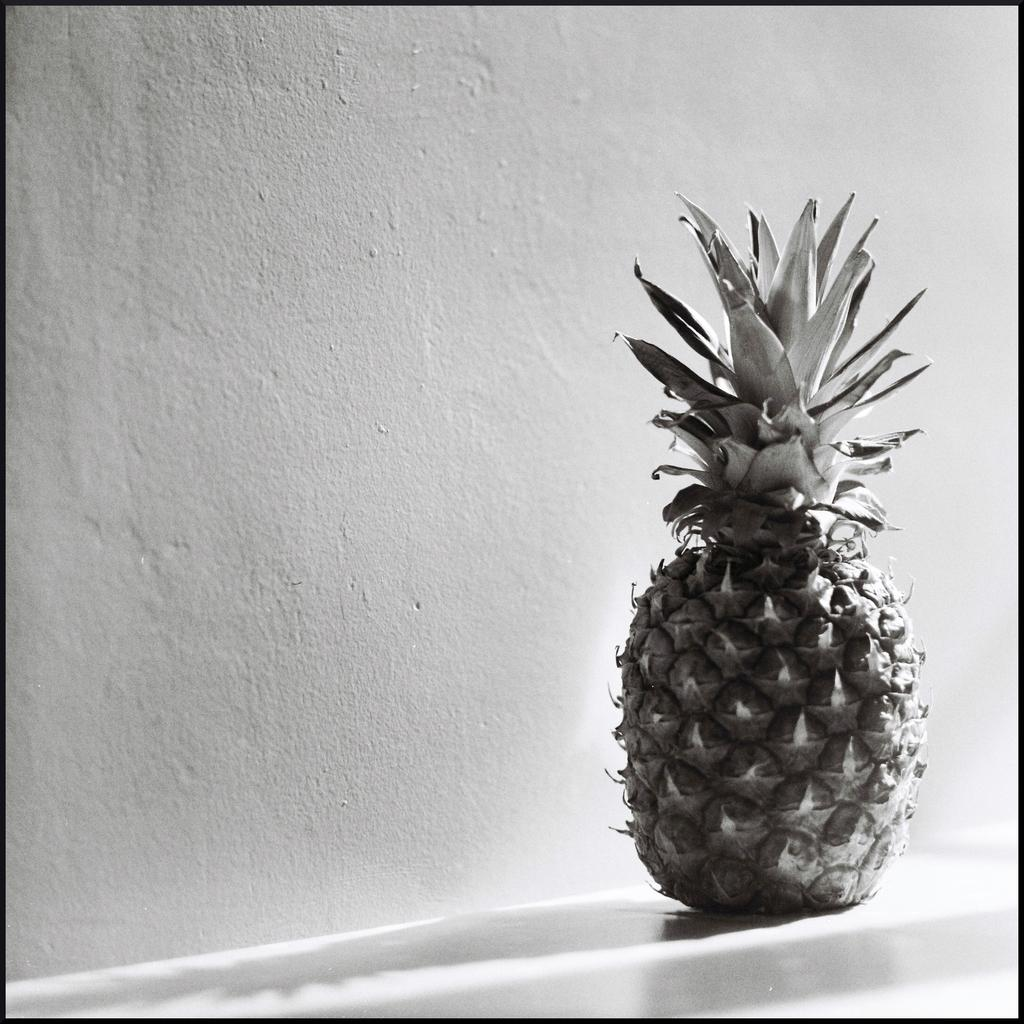What is the main subject in the foreground of the image? There is a pineapple in the foreground of the image. Where is the pineapple located? The pineapple is on the floor. What can be seen in the background of the image? There is a wall in the background of the image. What is the color of the wall? The wall is off-white in color. In which type of space was the image taken? The image was taken in a room. Can you tell me how many shops are visible in the image? There are no shops visible in the image; it features a pineapple on the floor in a room. Is there a stream running through the room in the image? There is no stream present in the image; it shows a pineapple on the floor in a room. 